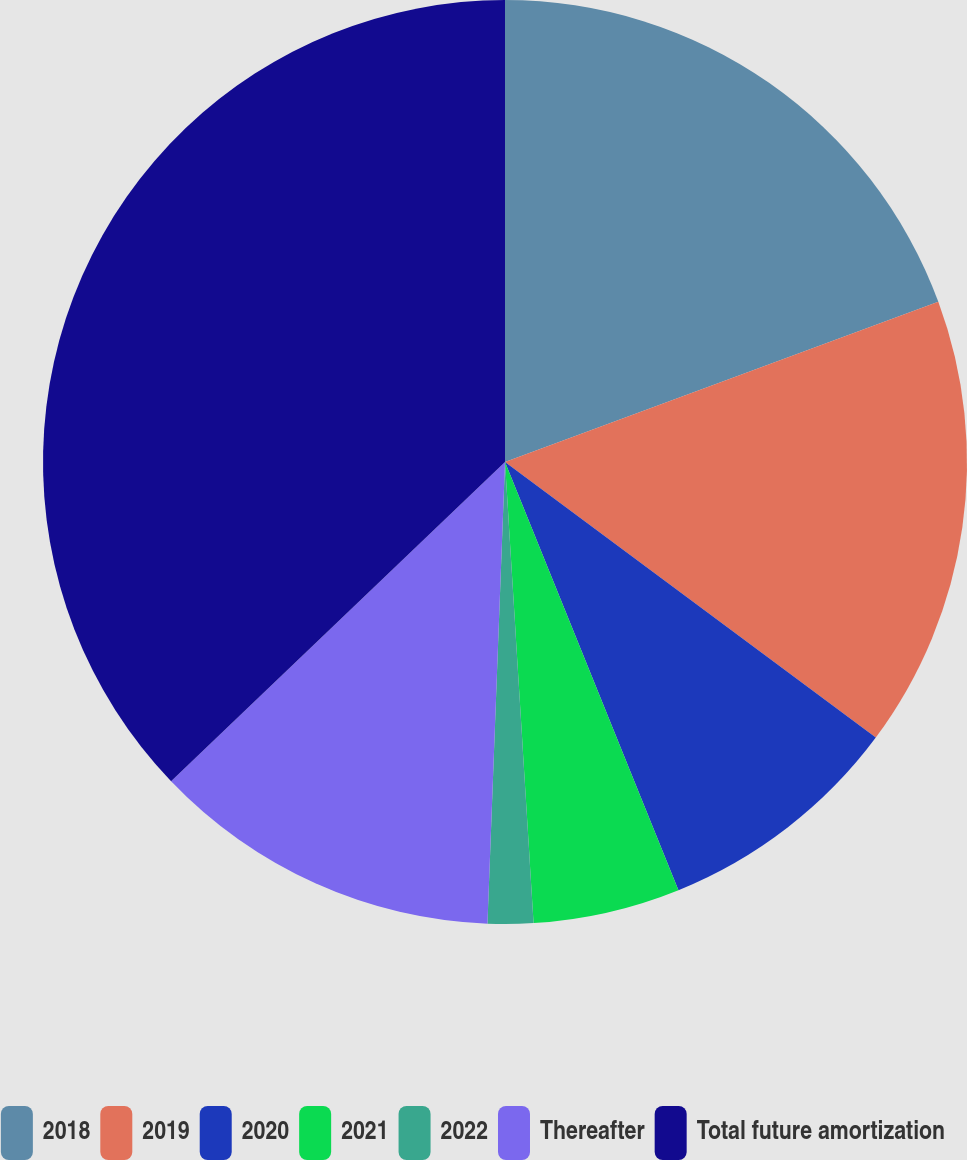Convert chart to OTSL. <chart><loc_0><loc_0><loc_500><loc_500><pie_chart><fcel>2018<fcel>2019<fcel>2020<fcel>2021<fcel>2022<fcel>Thereafter<fcel>Total future amortization<nl><fcel>19.36%<fcel>15.81%<fcel>8.7%<fcel>5.14%<fcel>1.59%<fcel>12.25%<fcel>37.14%<nl></chart> 